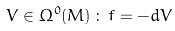Convert formula to latex. <formula><loc_0><loc_0><loc_500><loc_500>V \in \Omega ^ { 0 } ( M ) \, \colon \, f = - d V</formula> 